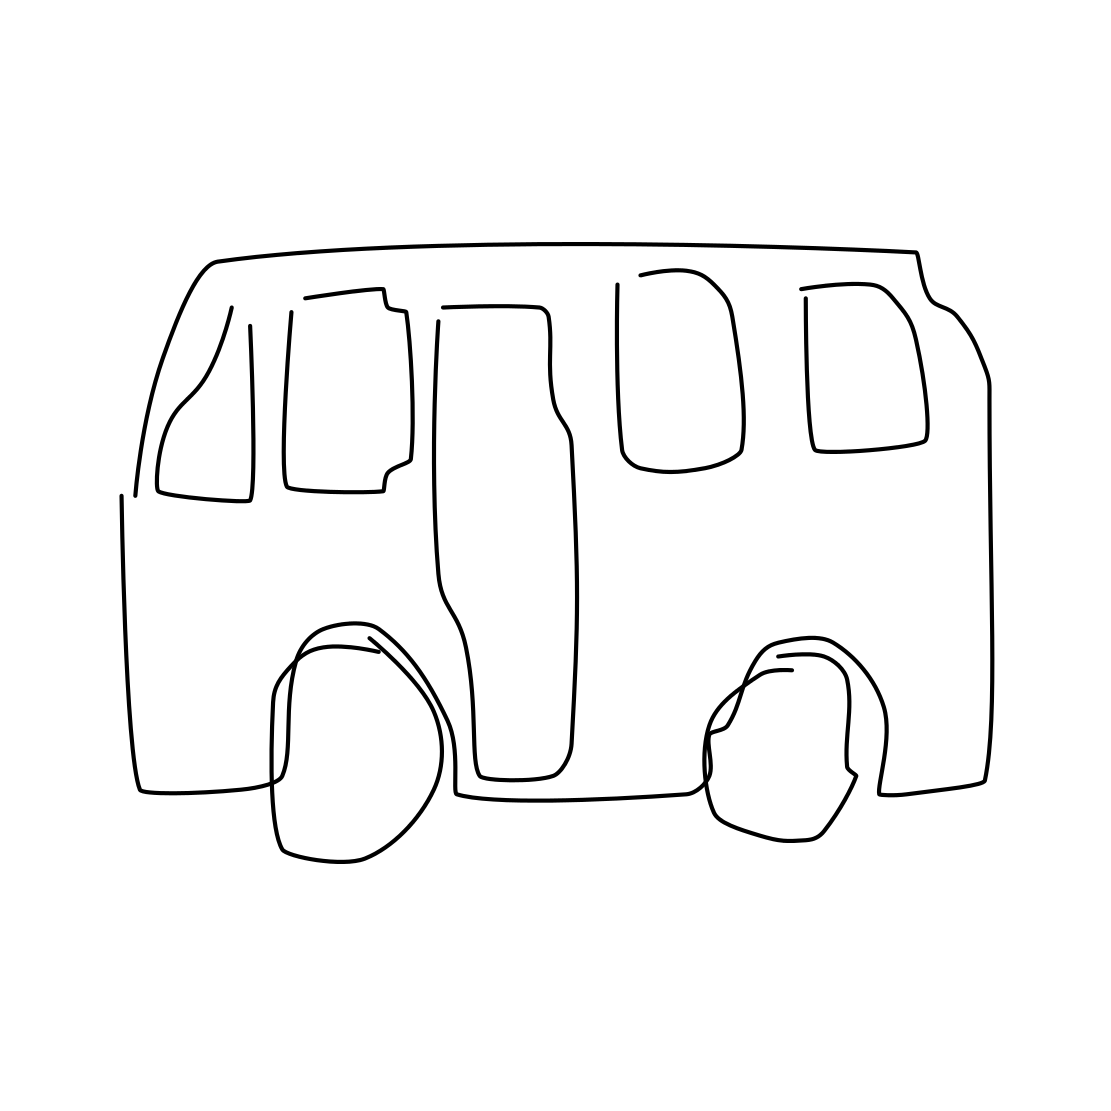Can you tell me what kind of vehicle is depicted here? Certainly! The image depicts a basic line drawing of a boxy, four-wheeled vehicle, which appears to be a stylized representation of a van or a similar type of vehicle typically used for transporting goods or people. 